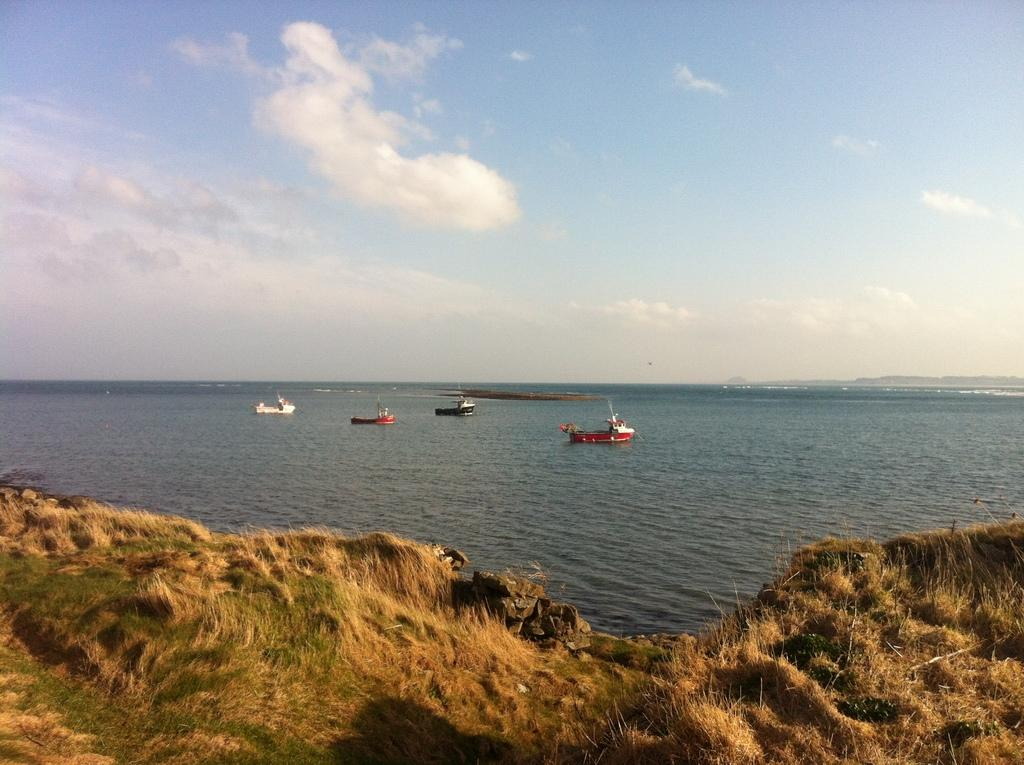What type of terrain is present on the ground in the image? There is grass on the ground in the image. What can be seen in the distance behind the grass? There is an ocean visible in the background of the image. What is floating on the water in the image? There are boats on the water in the image. What part of the natural environment is visible in the image? The sky is visible in the image. What is present in the sky in the image? There are clouds in the sky. What type of thread is being used to sew the owner's name on the boats in the image? There is no owner's name or thread present in the image; it features boats on the water with no visible text or sewing. 